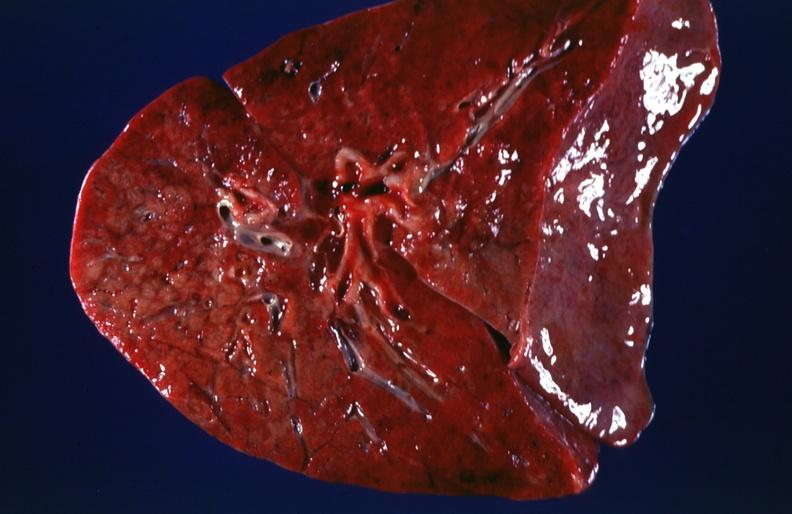s case of dic not bad photo present?
Answer the question using a single word or phrase. No 